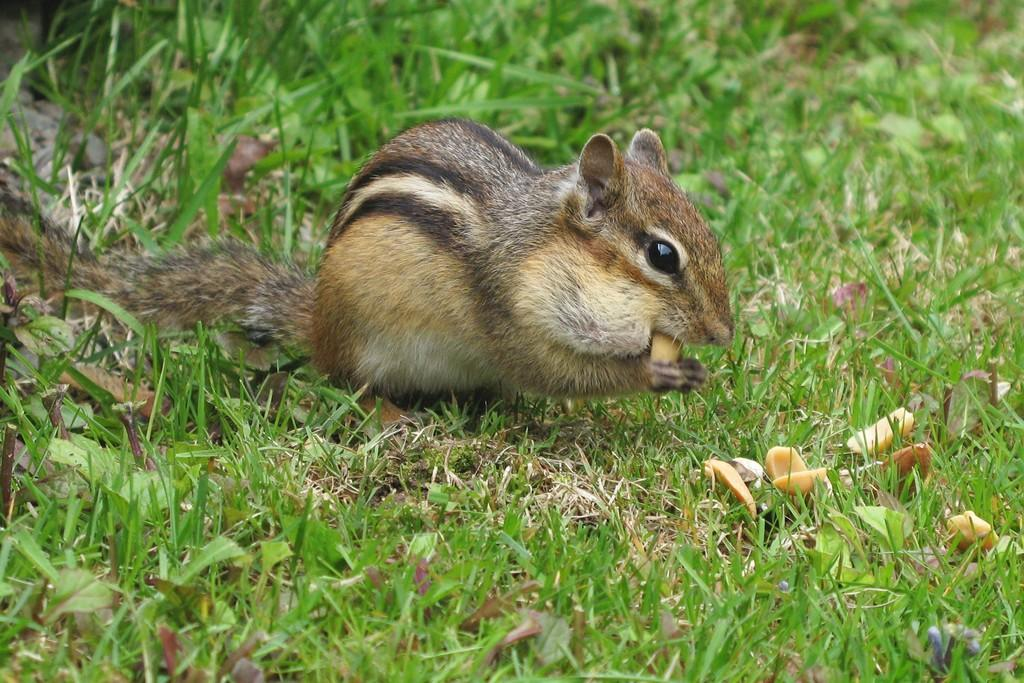What animal can be seen in the image? There is a squirrel in the image. What is the squirrel doing with its legs? The squirrel is holding food with its legs. What type of terrain is visible in the image? There is grass on the ground in the image. What colors make up the squirrel's fur? The squirrel is black, brown, and white in color. What type of punishment is the squirrel receiving in the image? There is no indication of punishment in the image; the squirrel is simply holding food with its legs. Where is the squirrel's bedroom located in the image? There is no bedroom present in the image, as it is an outdoor scene featuring a squirrel and grass. 